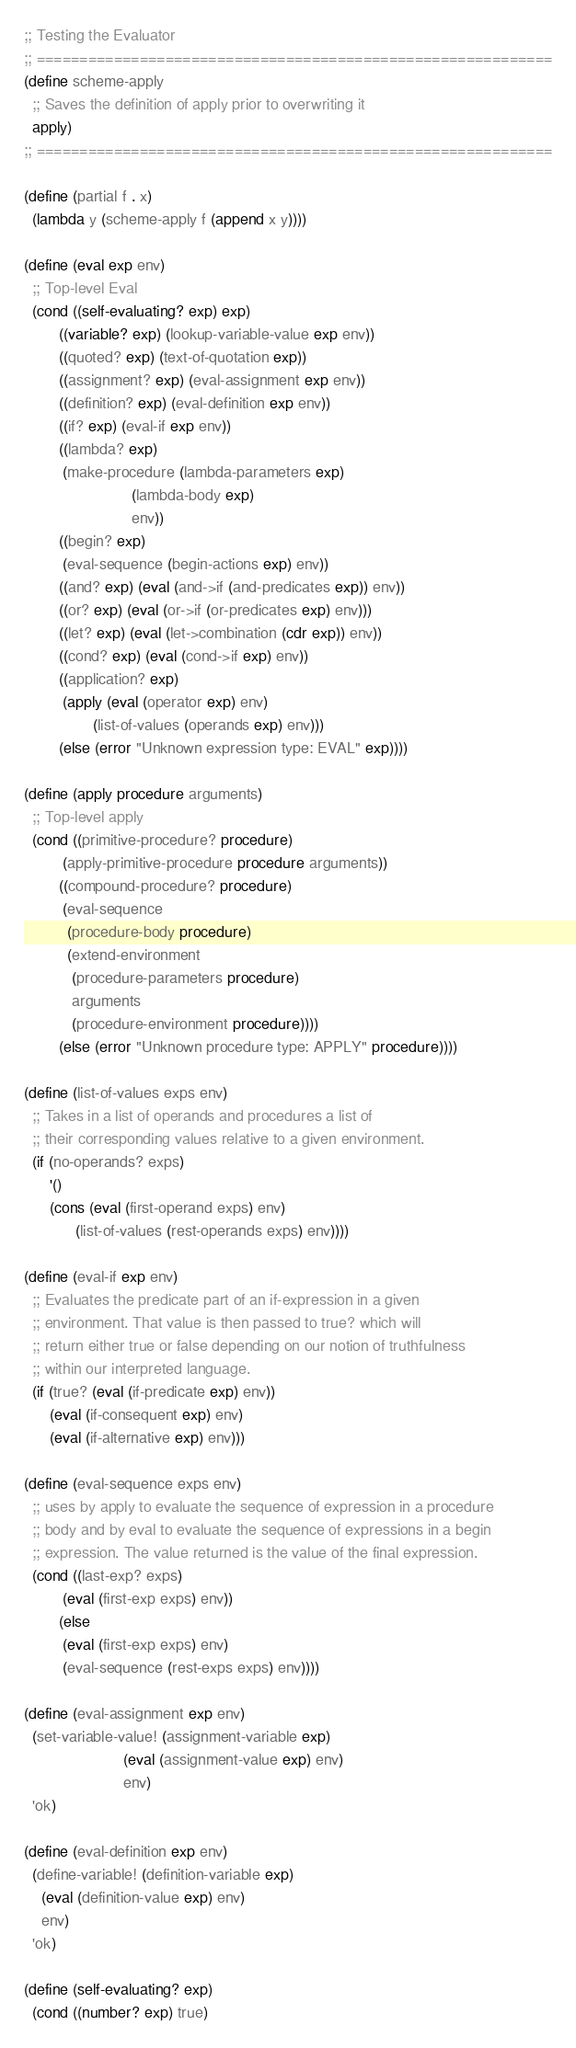<code> <loc_0><loc_0><loc_500><loc_500><_Scheme_>;; Testing the Evaluator
;; ============================================================
(define scheme-apply
  ;; Saves the definition of apply prior to overwriting it
  apply)
;; ============================================================

(define (partial f . x)
  (lambda y (scheme-apply f (append x y))))

(define (eval exp env)
  ;; Top-level Eval
  (cond ((self-evaluating? exp) exp)
        ((variable? exp) (lookup-variable-value exp env))
        ((quoted? exp) (text-of-quotation exp))
        ((assignment? exp) (eval-assignment exp env))
        ((definition? exp) (eval-definition exp env))
        ((if? exp) (eval-if exp env))
        ((lambda? exp)
         (make-procedure (lambda-parameters exp)
                         (lambda-body exp)
                         env))
        ((begin? exp)
         (eval-sequence (begin-actions exp) env))
        ((and? exp) (eval (and->if (and-predicates exp)) env))
        ((or? exp) (eval (or->if (or-predicates exp) env)))
        ((let? exp) (eval (let->combination (cdr exp)) env))
        ((cond? exp) (eval (cond->if exp) env))
        ((application? exp)
         (apply (eval (operator exp) env)
                (list-of-values (operands exp) env)))
        (else (error "Unknown expression type: EVAL" exp))))

(define (apply procedure arguments)
  ;; Top-level apply
  (cond ((primitive-procedure? procedure)
         (apply-primitive-procedure procedure arguments))
        ((compound-procedure? procedure)
         (eval-sequence
          (procedure-body procedure)
          (extend-environment
           (procedure-parameters procedure)
           arguments
           (procedure-environment procedure))))
        (else (error "Unknown procedure type: APPLY" procedure))))

(define (list-of-values exps env)
  ;; Takes in a list of operands and procedures a list of
  ;; their corresponding values relative to a given environment.
  (if (no-operands? exps)
      '()
      (cons (eval (first-operand exps) env)
            (list-of-values (rest-operands exps) env))))

(define (eval-if exp env)
  ;; Evaluates the predicate part of an if-expression in a given
  ;; environment. That value is then passed to true? which will
  ;; return either true or false depending on our notion of truthfulness
  ;; within our interpreted language.
  (if (true? (eval (if-predicate exp) env))
      (eval (if-consequent exp) env)
      (eval (if-alternative exp) env)))

(define (eval-sequence exps env)
  ;; uses by apply to evaluate the sequence of expression in a procedure
  ;; body and by eval to evaluate the sequence of expressions in a begin
  ;; expression. The value returned is the value of the final expression.
  (cond ((last-exp? exps)
         (eval (first-exp exps) env))
        (else
         (eval (first-exp exps) env)
         (eval-sequence (rest-exps exps) env))))

(define (eval-assignment exp env)
  (set-variable-value! (assignment-variable exp)
                       (eval (assignment-value exp) env)
                       env)
  'ok)

(define (eval-definition exp env)
  (define-variable! (definition-variable exp)
    (eval (definition-value exp) env)
    env)
  'ok)

(define (self-evaluating? exp)
  (cond ((number? exp) true)</code> 